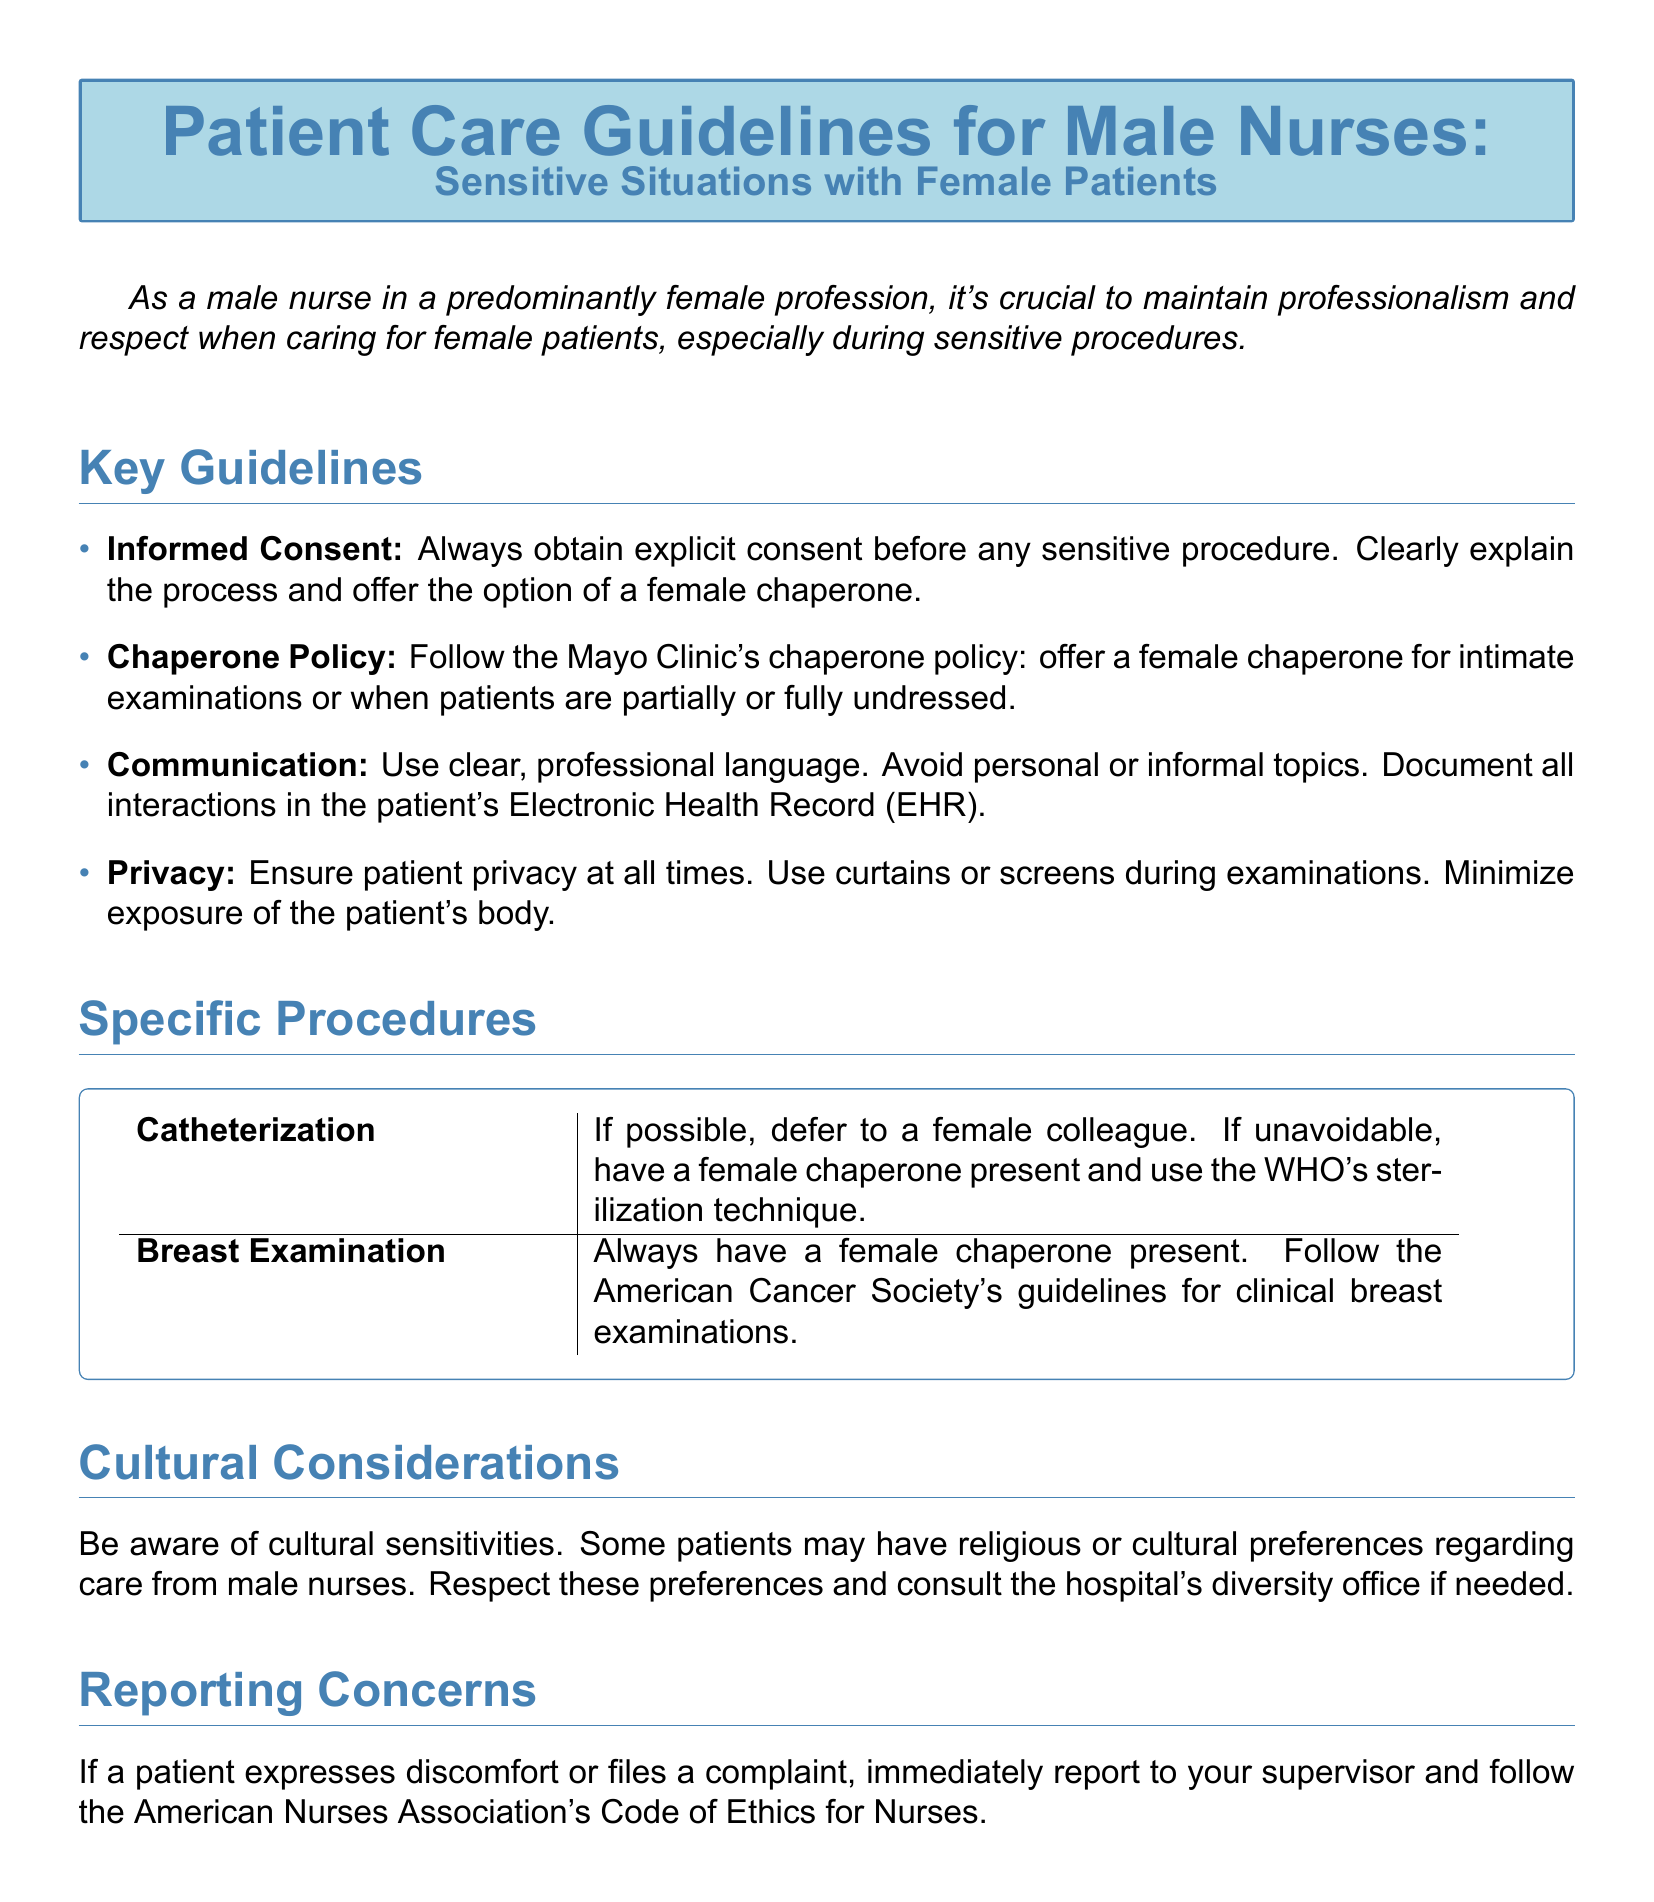What must be obtained before any sensitive procedure? The document states that explicit consent must be obtained before any sensitive procedure.
Answer: Informed Consent What policy should be followed regarding chaperones? The document references the Mayo Clinic's chaperone policy, which involves offering a female chaperone for intimate examinations.
Answer: Chaperone Policy What should be used to ensure patient privacy during examinations? The document specifies that curtains or screens should be used to ensure patient privacy.
Answer: Curtains or screens Which organization's guidelines are to be followed for breast examinations? The document mentions that the American Cancer Society's guidelines should be followed for clinical breast examinations.
Answer: American Cancer Society What action should be taken if a patient files a complaint? The document advises reporting to your supervisor if a patient expresses discomfort or files a complaint.
Answer: Report to your supervisor What additional support might be needed due to cultural considerations? The document highlights the importance of consulting the hospital's diversity office for cultural sensitivities.
Answer: Diversity office How should communication with patients be conducted? The document emphasizes using clear, professional language and avoiding informal topics during communication with patients.
Answer: Clear, professional language What should be present during catheterization if unavoidable? The document states that a female chaperone should be present during catheterization if unavoidable.
Answer: Female chaperone 